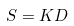<formula> <loc_0><loc_0><loc_500><loc_500>S = K D</formula> 